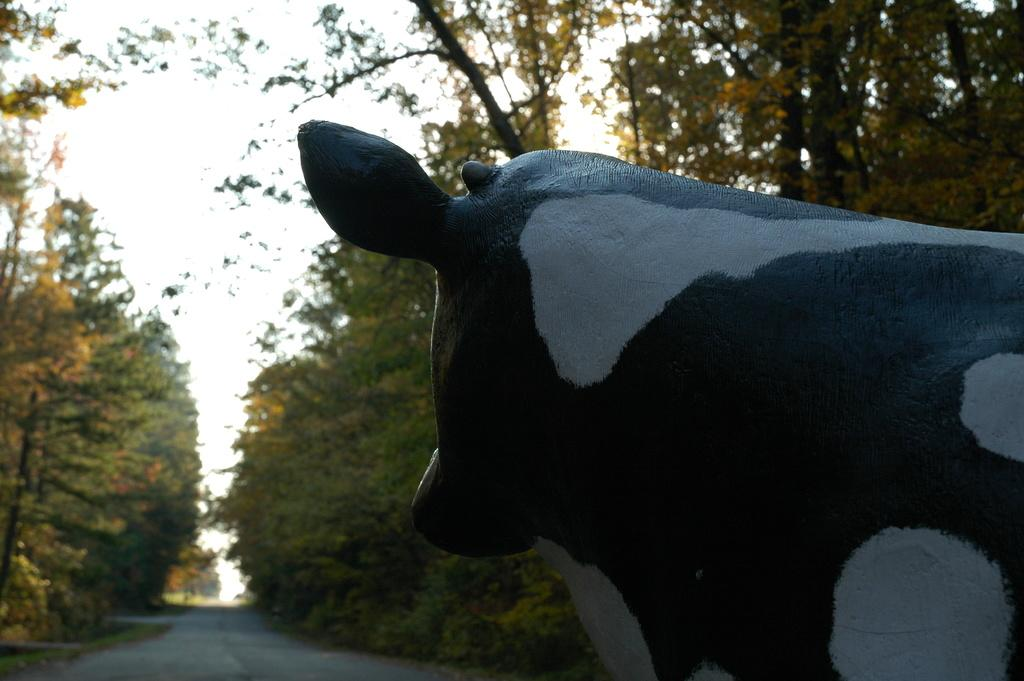What type of object is depicted as a statue in the image? There is a statue of an animal in the image. What can be seen in the foreground of the image? There is a road visible in the image. What type of vegetation is present in the image? There are trees in the image. What is visible in the background of the image? The sky is visible in the background of the image. What type of needle is being used to sew the circle in the image? There is no needle or circle present in the image. 